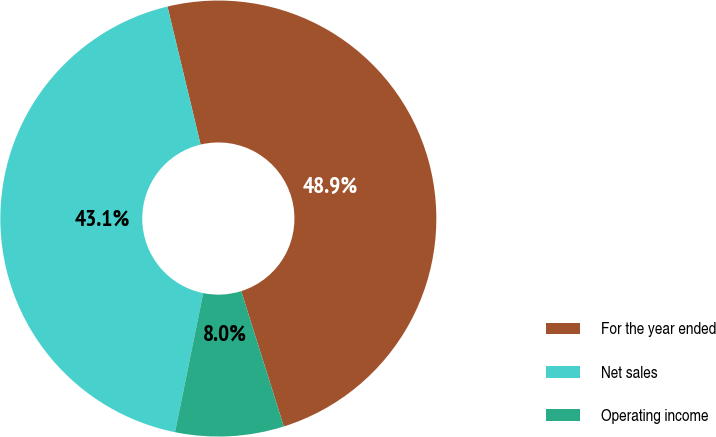Convert chart. <chart><loc_0><loc_0><loc_500><loc_500><pie_chart><fcel>For the year ended<fcel>Net sales<fcel>Operating income<nl><fcel>48.9%<fcel>43.07%<fcel>8.04%<nl></chart> 